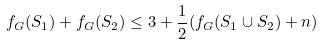Convert formula to latex. <formula><loc_0><loc_0><loc_500><loc_500>f _ { G } ( S _ { 1 } ) + f _ { G } ( S _ { 2 } ) \leq 3 + \frac { 1 } { 2 } ( f _ { G } ( S _ { 1 } \cup S _ { 2 } ) + n )</formula> 